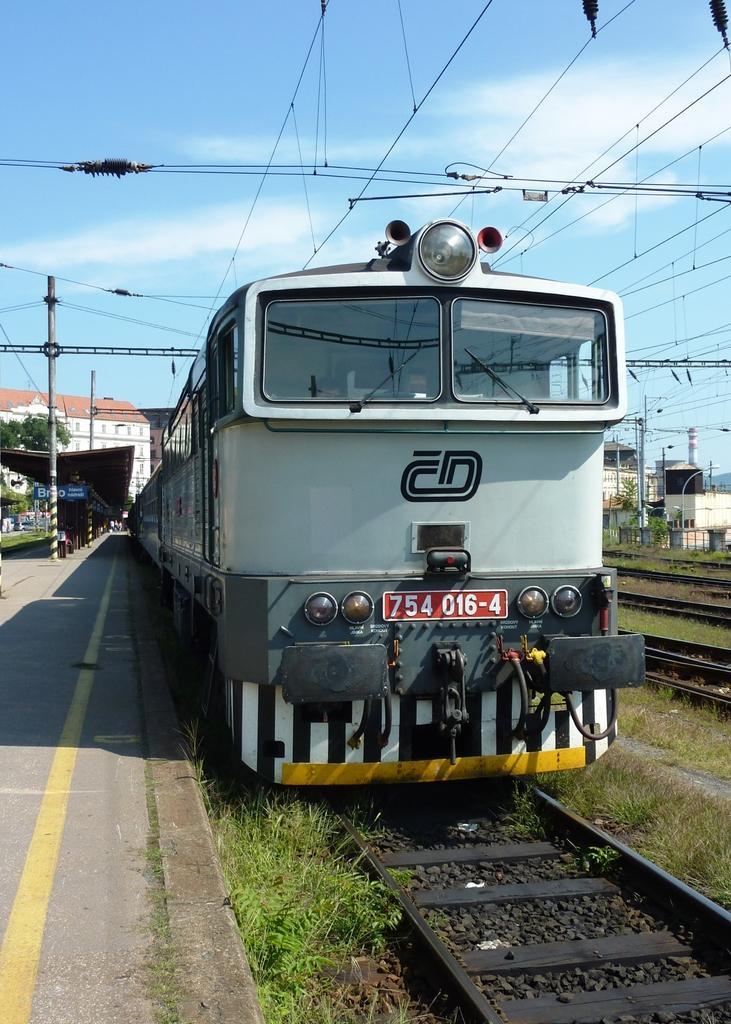How would you summarize this image in a sentence or two? In this picture there is a train on the track. The train is in grey in color. Towards the left there is a platform with poles. On the top there is a sky and wires. 